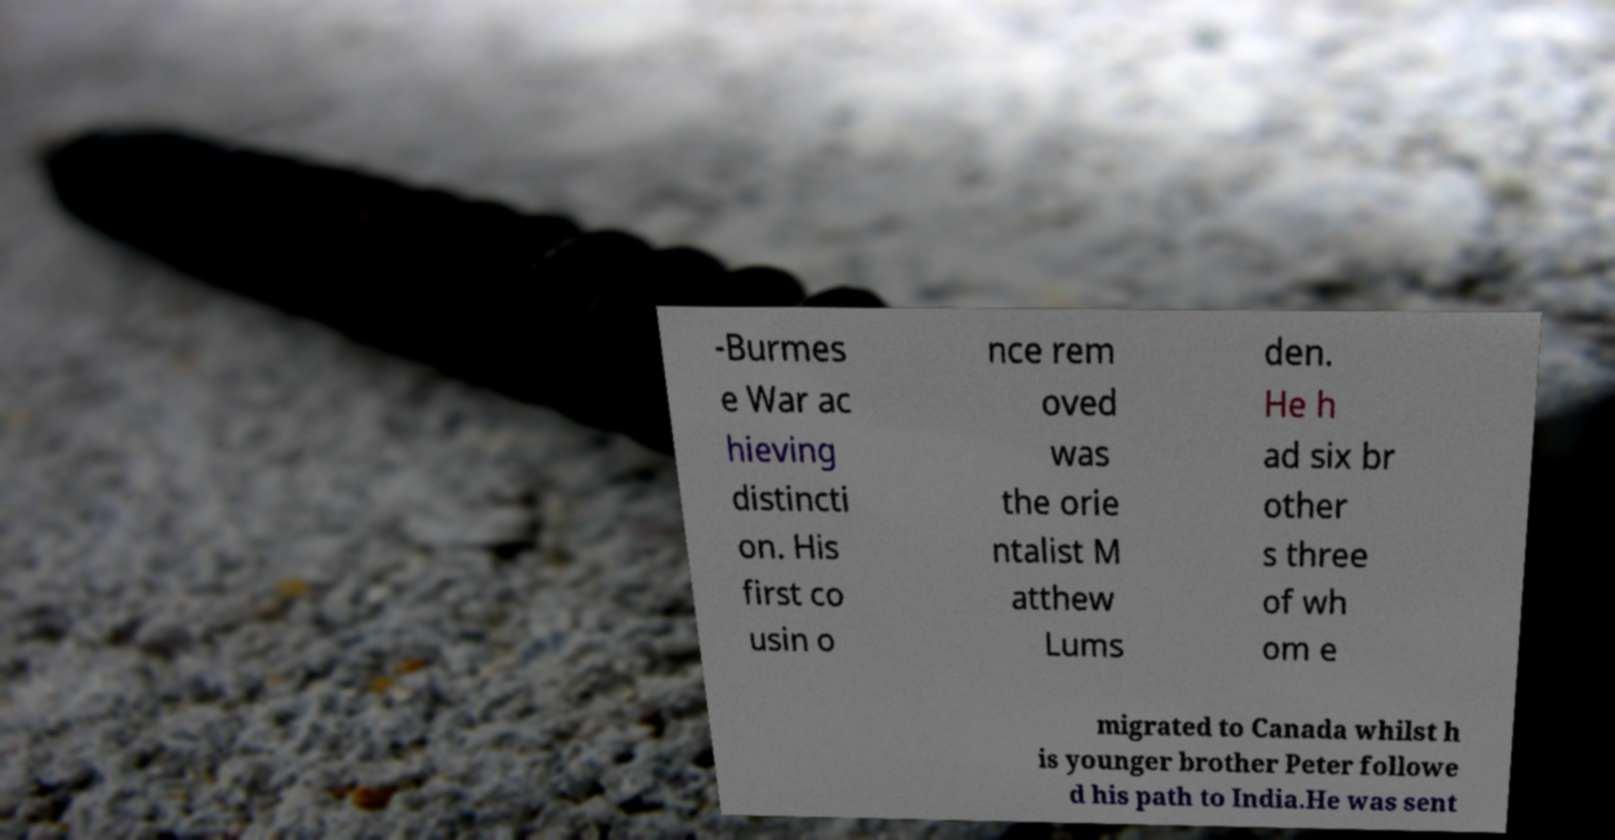Could you extract and type out the text from this image? -Burmes e War ac hieving distincti on. His first co usin o nce rem oved was the orie ntalist M atthew Lums den. He h ad six br other s three of wh om e migrated to Canada whilst h is younger brother Peter followe d his path to India.He was sent 